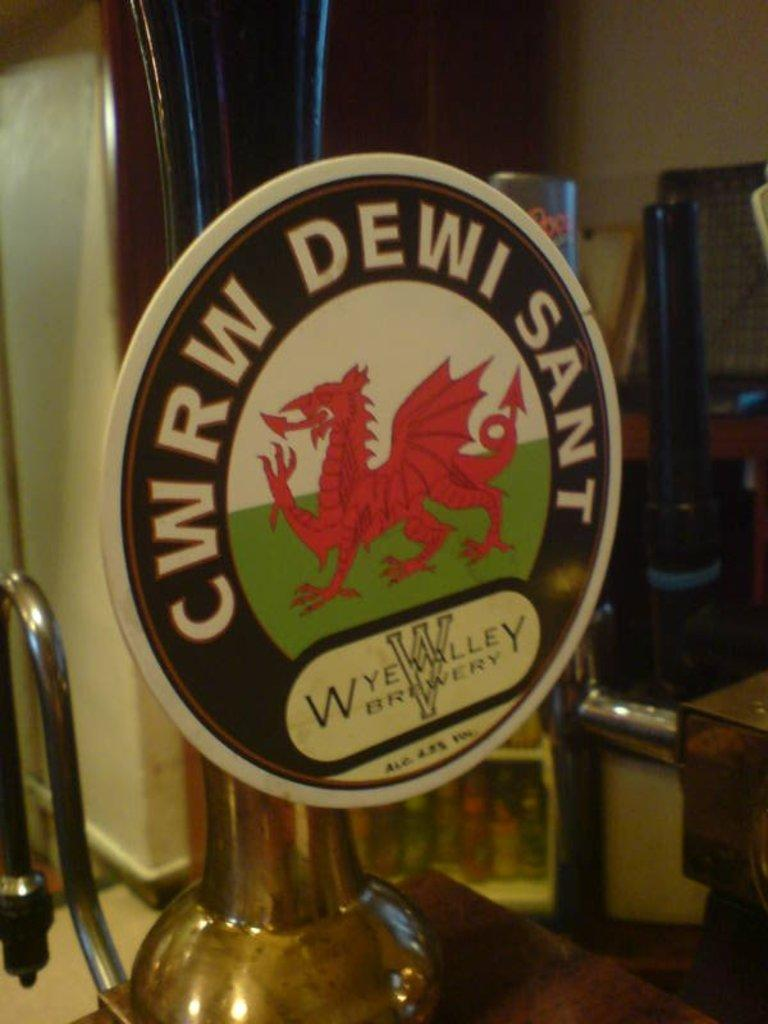<image>
Relay a brief, clear account of the picture shown. a CWRW DEWI Sant sign with a dragon on it 